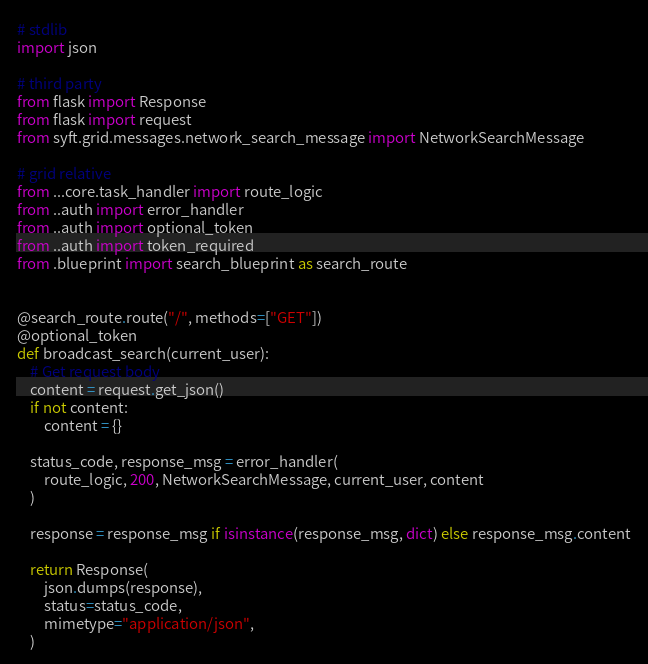Convert code to text. <code><loc_0><loc_0><loc_500><loc_500><_Python_># stdlib
import json

# third party
from flask import Response
from flask import request
from syft.grid.messages.network_search_message import NetworkSearchMessage

# grid relative
from ...core.task_handler import route_logic
from ..auth import error_handler
from ..auth import optional_token
from ..auth import token_required
from .blueprint import search_blueprint as search_route


@search_route.route("/", methods=["GET"])
@optional_token
def broadcast_search(current_user):
    # Get request body
    content = request.get_json()
    if not content:
        content = {}

    status_code, response_msg = error_handler(
        route_logic, 200, NetworkSearchMessage, current_user, content
    )

    response = response_msg if isinstance(response_msg, dict) else response_msg.content

    return Response(
        json.dumps(response),
        status=status_code,
        mimetype="application/json",
    )
</code> 